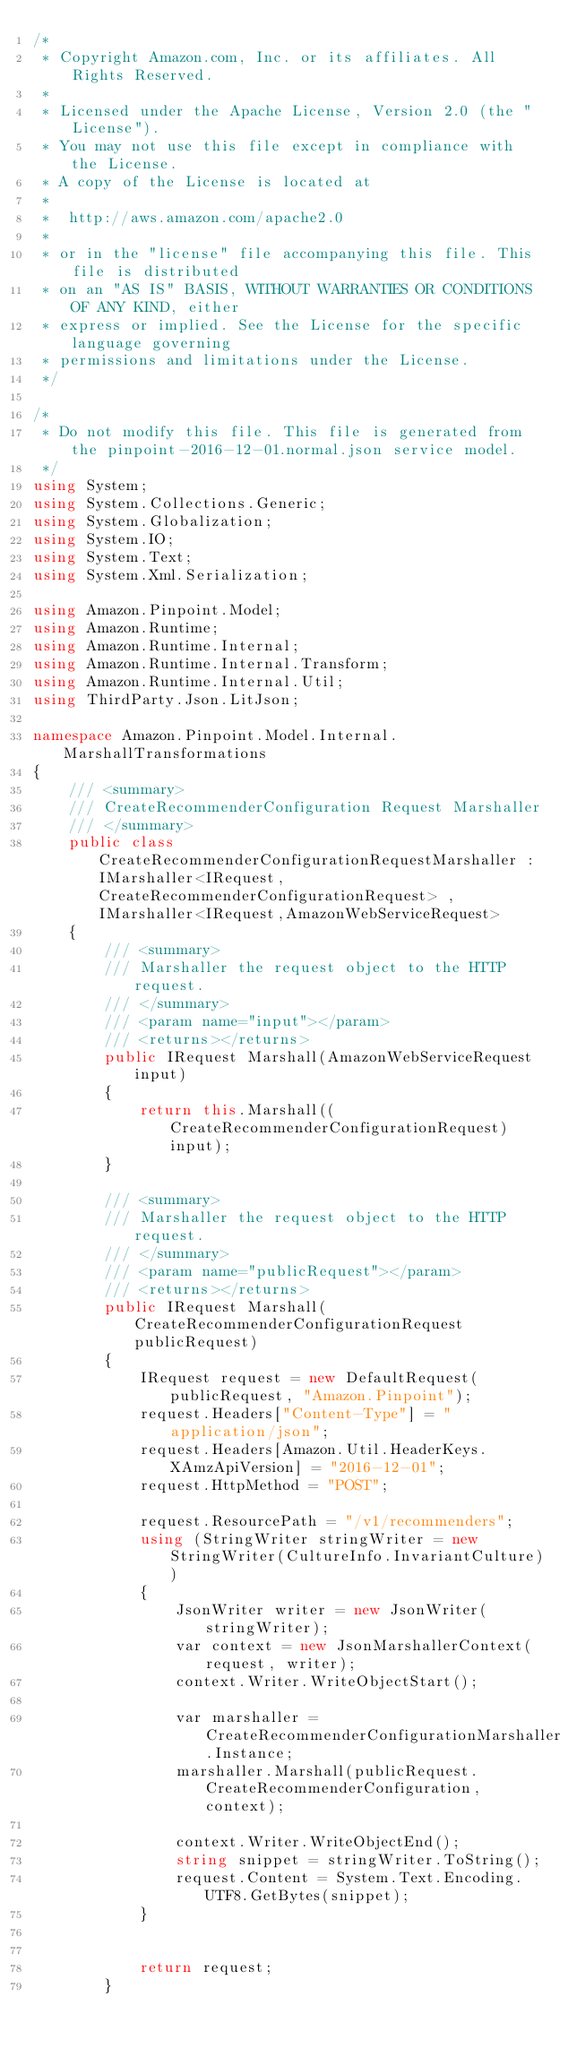<code> <loc_0><loc_0><loc_500><loc_500><_C#_>/*
 * Copyright Amazon.com, Inc. or its affiliates. All Rights Reserved.
 * 
 * Licensed under the Apache License, Version 2.0 (the "License").
 * You may not use this file except in compliance with the License.
 * A copy of the License is located at
 * 
 *  http://aws.amazon.com/apache2.0
 * 
 * or in the "license" file accompanying this file. This file is distributed
 * on an "AS IS" BASIS, WITHOUT WARRANTIES OR CONDITIONS OF ANY KIND, either
 * express or implied. See the License for the specific language governing
 * permissions and limitations under the License.
 */

/*
 * Do not modify this file. This file is generated from the pinpoint-2016-12-01.normal.json service model.
 */
using System;
using System.Collections.Generic;
using System.Globalization;
using System.IO;
using System.Text;
using System.Xml.Serialization;

using Amazon.Pinpoint.Model;
using Amazon.Runtime;
using Amazon.Runtime.Internal;
using Amazon.Runtime.Internal.Transform;
using Amazon.Runtime.Internal.Util;
using ThirdParty.Json.LitJson;

namespace Amazon.Pinpoint.Model.Internal.MarshallTransformations
{
    /// <summary>
    /// CreateRecommenderConfiguration Request Marshaller
    /// </summary>       
    public class CreateRecommenderConfigurationRequestMarshaller : IMarshaller<IRequest, CreateRecommenderConfigurationRequest> , IMarshaller<IRequest,AmazonWebServiceRequest>
    {
        /// <summary>
        /// Marshaller the request object to the HTTP request.
        /// </summary>  
        /// <param name="input"></param>
        /// <returns></returns>
        public IRequest Marshall(AmazonWebServiceRequest input)
        {
            return this.Marshall((CreateRecommenderConfigurationRequest)input);
        }

        /// <summary>
        /// Marshaller the request object to the HTTP request.
        /// </summary>  
        /// <param name="publicRequest"></param>
        /// <returns></returns>
        public IRequest Marshall(CreateRecommenderConfigurationRequest publicRequest)
        {
            IRequest request = new DefaultRequest(publicRequest, "Amazon.Pinpoint");
            request.Headers["Content-Type"] = "application/json";
            request.Headers[Amazon.Util.HeaderKeys.XAmzApiVersion] = "2016-12-01";            
            request.HttpMethod = "POST";

            request.ResourcePath = "/v1/recommenders";
            using (StringWriter stringWriter = new StringWriter(CultureInfo.InvariantCulture))
            {
                JsonWriter writer = new JsonWriter(stringWriter);
                var context = new JsonMarshallerContext(request, writer);
                context.Writer.WriteObjectStart();

                var marshaller = CreateRecommenderConfigurationMarshaller.Instance;
                marshaller.Marshall(publicRequest.CreateRecommenderConfiguration, context);

                context.Writer.WriteObjectEnd();
                string snippet = stringWriter.ToString();
                request.Content = System.Text.Encoding.UTF8.GetBytes(snippet);
            }


            return request;
        }</code> 